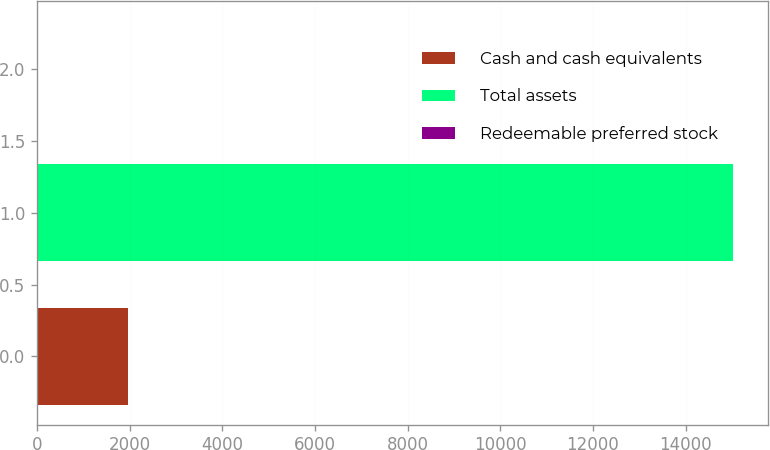Convert chart. <chart><loc_0><loc_0><loc_500><loc_500><bar_chart><fcel>Cash and cash equivalents<fcel>Total assets<fcel>Redeemable preferred stock<nl><fcel>1951<fcel>15035<fcel>20<nl></chart> 